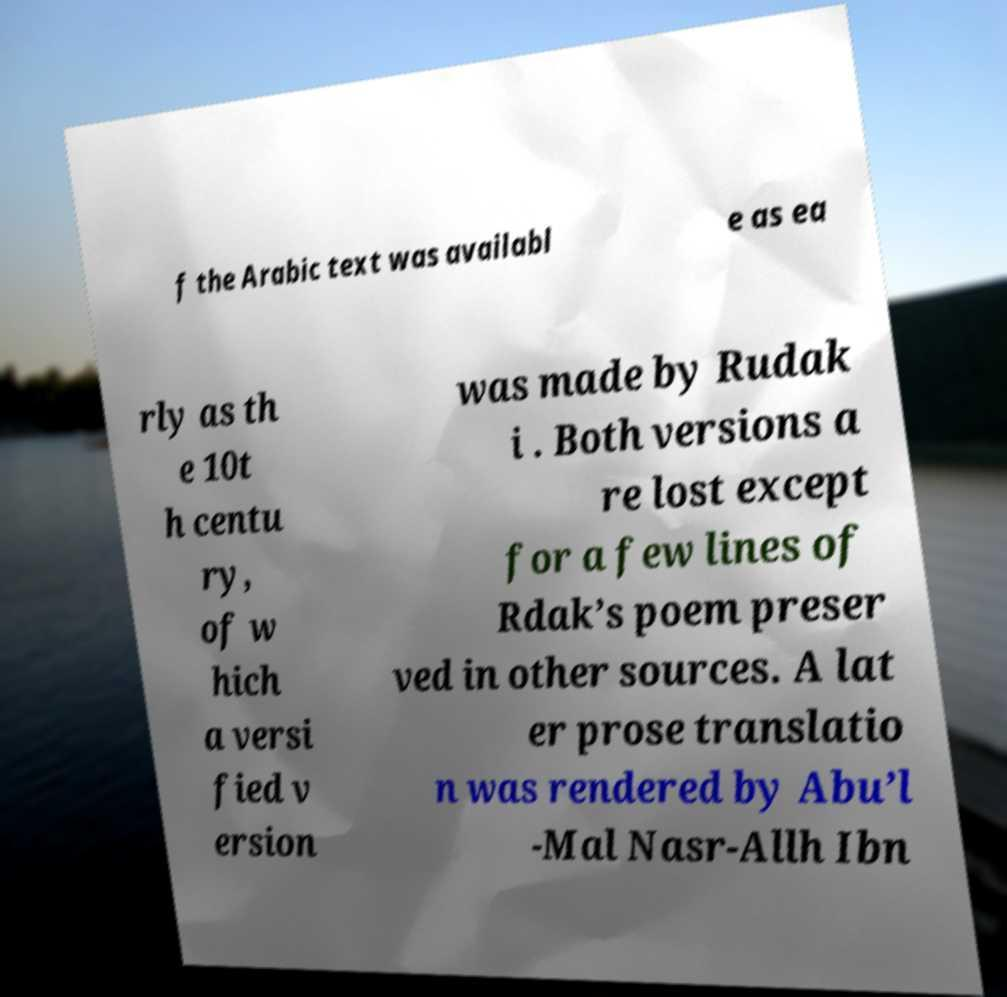Could you extract and type out the text from this image? f the Arabic text was availabl e as ea rly as th e 10t h centu ry, of w hich a versi fied v ersion was made by Rudak i . Both versions a re lost except for a few lines of Rdak’s poem preser ved in other sources. A lat er prose translatio n was rendered by Abu’l -Mal Nasr-Allh Ibn 